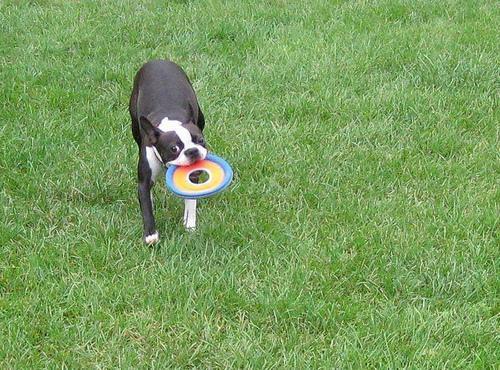How many dogs are in the photo?
Give a very brief answer. 1. 